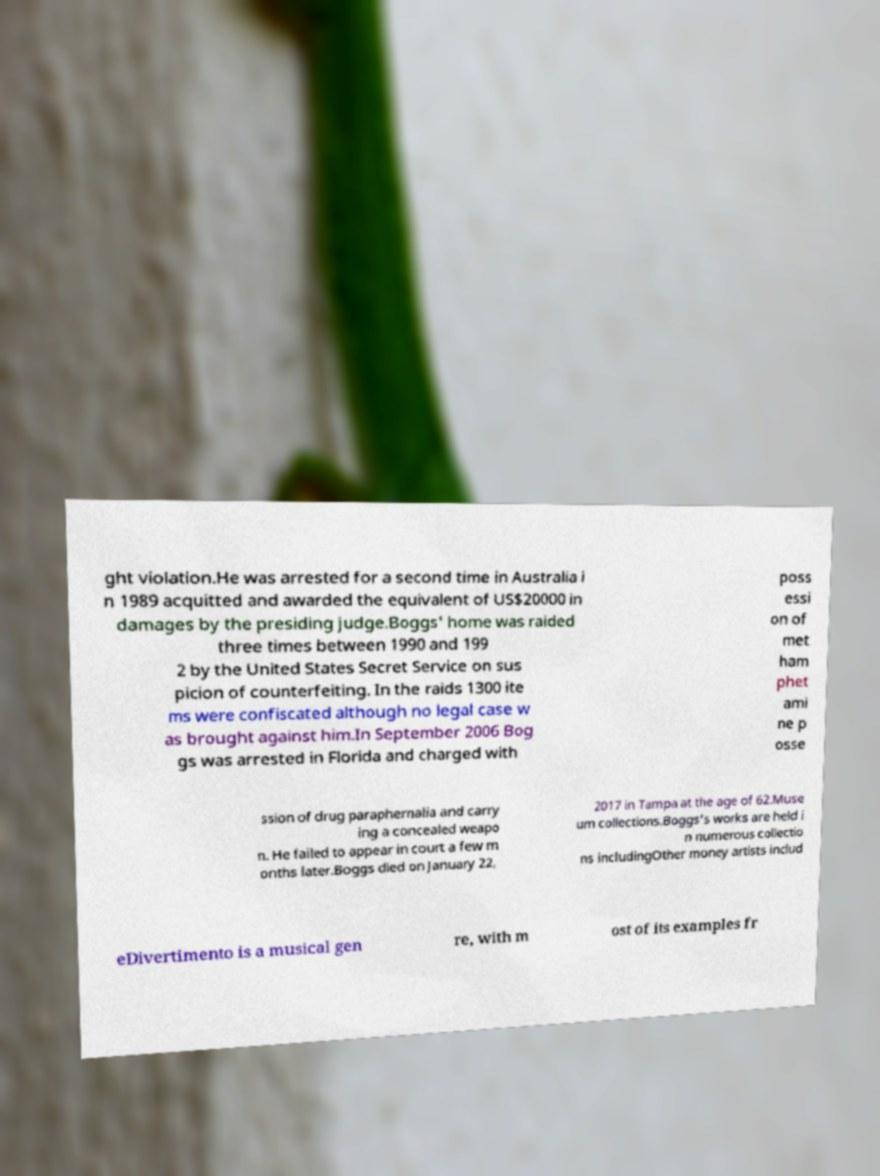I need the written content from this picture converted into text. Can you do that? ght violation.He was arrested for a second time in Australia i n 1989 acquitted and awarded the equivalent of US$20000 in damages by the presiding judge.Boggs' home was raided three times between 1990 and 199 2 by the United States Secret Service on sus picion of counterfeiting. In the raids 1300 ite ms were confiscated although no legal case w as brought against him.In September 2006 Bog gs was arrested in Florida and charged with poss essi on of met ham phet ami ne p osse ssion of drug paraphernalia and carry ing a concealed weapo n. He failed to appear in court a few m onths later.Boggs died on January 22, 2017 in Tampa at the age of 62.Muse um collections.Boggs's works are held i n numerous collectio ns includingOther money artists includ eDivertimento is a musical gen re, with m ost of its examples fr 